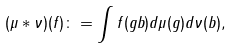<formula> <loc_0><loc_0><loc_500><loc_500>( \mu * \nu ) ( f ) \colon = \int f ( g b ) d \mu ( g ) d \nu ( b ) ,</formula> 